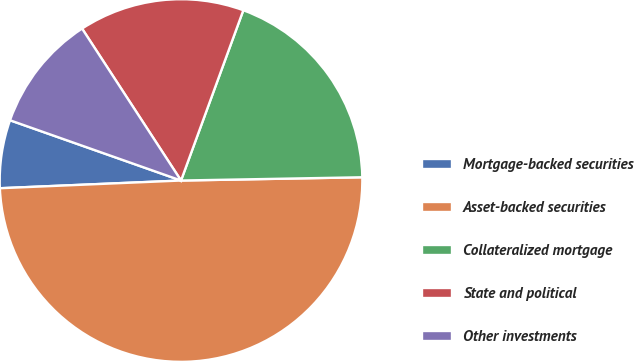<chart> <loc_0><loc_0><loc_500><loc_500><pie_chart><fcel>Mortgage-backed securities<fcel>Asset-backed securities<fcel>Collateralized mortgage<fcel>State and political<fcel>Other investments<nl><fcel>6.07%<fcel>49.61%<fcel>19.13%<fcel>14.77%<fcel>10.42%<nl></chart> 